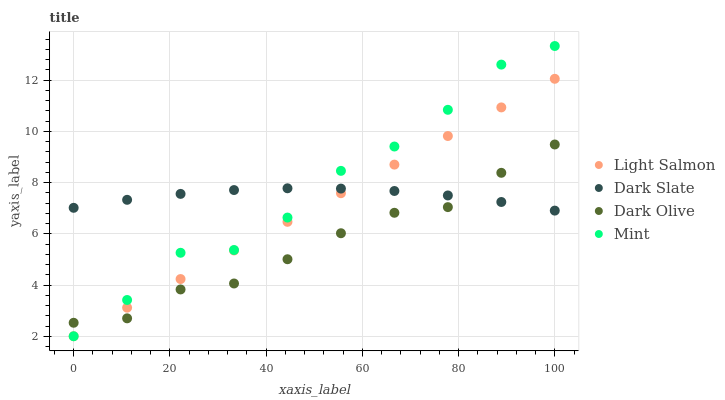Does Dark Olive have the minimum area under the curve?
Answer yes or no. Yes. Does Mint have the maximum area under the curve?
Answer yes or no. Yes. Does Light Salmon have the minimum area under the curve?
Answer yes or no. No. Does Light Salmon have the maximum area under the curve?
Answer yes or no. No. Is Light Salmon the smoothest?
Answer yes or no. Yes. Is Mint the roughest?
Answer yes or no. Yes. Is Dark Olive the smoothest?
Answer yes or no. No. Is Dark Olive the roughest?
Answer yes or no. No. Does Light Salmon have the lowest value?
Answer yes or no. Yes. Does Dark Olive have the lowest value?
Answer yes or no. No. Does Mint have the highest value?
Answer yes or no. Yes. Does Light Salmon have the highest value?
Answer yes or no. No. Does Dark Olive intersect Light Salmon?
Answer yes or no. Yes. Is Dark Olive less than Light Salmon?
Answer yes or no. No. Is Dark Olive greater than Light Salmon?
Answer yes or no. No. 